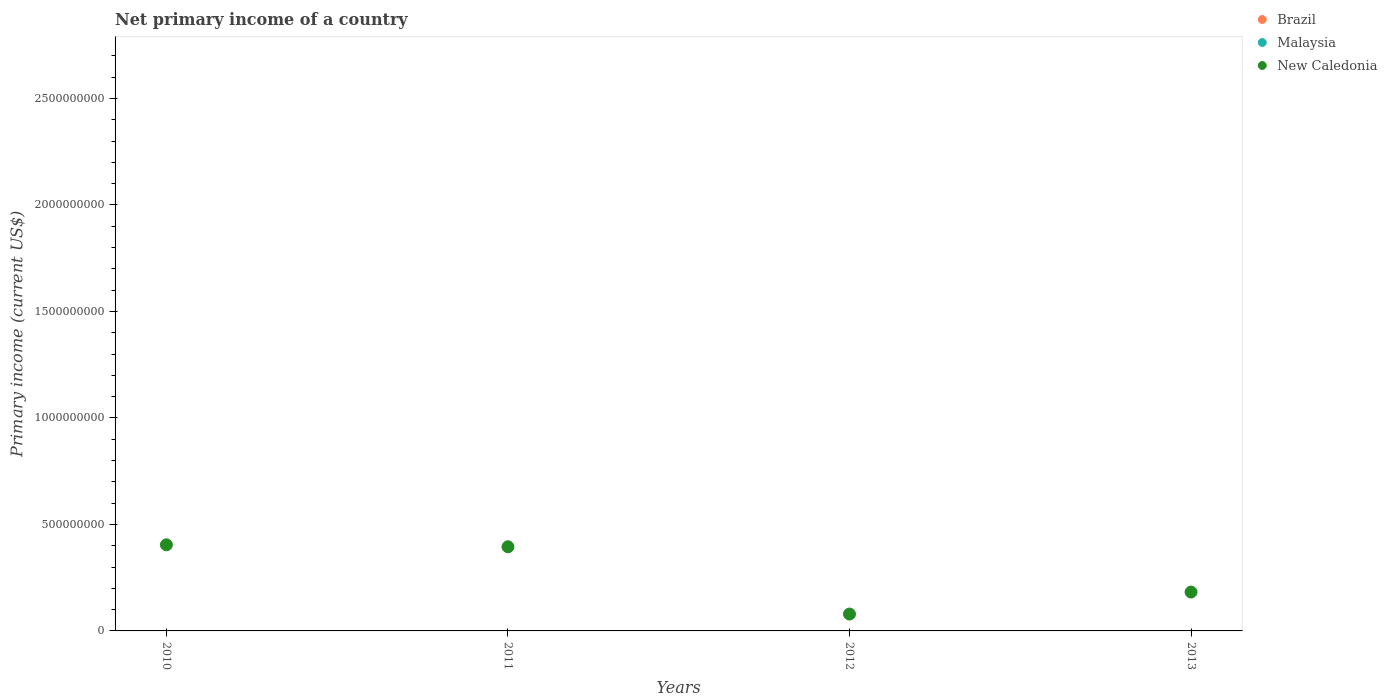Across all years, what is the maximum primary income in New Caledonia?
Your answer should be very brief. 4.04e+08. In which year was the primary income in New Caledonia maximum?
Keep it short and to the point. 2010. What is the difference between the primary income in New Caledonia in 2010 and that in 2012?
Your response must be concise. 3.25e+08. What is the difference between the primary income in New Caledonia in 2013 and the primary income in Malaysia in 2010?
Your answer should be very brief. 1.82e+08. What is the average primary income in Malaysia per year?
Provide a succinct answer. 0. What is the ratio of the primary income in New Caledonia in 2010 to that in 2012?
Offer a terse response. 5.11. What is the difference between the highest and the second highest primary income in New Caledonia?
Offer a very short reply. 9.33e+06. What is the difference between the highest and the lowest primary income in New Caledonia?
Your answer should be very brief. 3.25e+08. Is it the case that in every year, the sum of the primary income in New Caledonia and primary income in Malaysia  is greater than the primary income in Brazil?
Keep it short and to the point. Yes. Does the primary income in Malaysia monotonically increase over the years?
Offer a very short reply. No. How many years are there in the graph?
Offer a very short reply. 4. What is the difference between two consecutive major ticks on the Y-axis?
Provide a short and direct response. 5.00e+08. Are the values on the major ticks of Y-axis written in scientific E-notation?
Your answer should be compact. No. Does the graph contain grids?
Keep it short and to the point. No. Where does the legend appear in the graph?
Provide a short and direct response. Top right. What is the title of the graph?
Ensure brevity in your answer.  Net primary income of a country. Does "Middle East & North Africa (all income levels)" appear as one of the legend labels in the graph?
Your answer should be compact. No. What is the label or title of the Y-axis?
Make the answer very short. Primary income (current US$). What is the Primary income (current US$) in New Caledonia in 2010?
Make the answer very short. 4.04e+08. What is the Primary income (current US$) in Brazil in 2011?
Your answer should be very brief. 0. What is the Primary income (current US$) in New Caledonia in 2011?
Make the answer very short. 3.95e+08. What is the Primary income (current US$) in Malaysia in 2012?
Ensure brevity in your answer.  0. What is the Primary income (current US$) of New Caledonia in 2012?
Offer a very short reply. 7.92e+07. What is the Primary income (current US$) in Brazil in 2013?
Provide a short and direct response. 0. What is the Primary income (current US$) of Malaysia in 2013?
Ensure brevity in your answer.  0. What is the Primary income (current US$) in New Caledonia in 2013?
Keep it short and to the point. 1.82e+08. Across all years, what is the maximum Primary income (current US$) in New Caledonia?
Provide a short and direct response. 4.04e+08. Across all years, what is the minimum Primary income (current US$) of New Caledonia?
Your response must be concise. 7.92e+07. What is the total Primary income (current US$) in Brazil in the graph?
Keep it short and to the point. 0. What is the total Primary income (current US$) in New Caledonia in the graph?
Your response must be concise. 1.06e+09. What is the difference between the Primary income (current US$) of New Caledonia in 2010 and that in 2011?
Make the answer very short. 9.33e+06. What is the difference between the Primary income (current US$) of New Caledonia in 2010 and that in 2012?
Keep it short and to the point. 3.25e+08. What is the difference between the Primary income (current US$) of New Caledonia in 2010 and that in 2013?
Offer a terse response. 2.22e+08. What is the difference between the Primary income (current US$) of New Caledonia in 2011 and that in 2012?
Your answer should be very brief. 3.16e+08. What is the difference between the Primary income (current US$) of New Caledonia in 2011 and that in 2013?
Offer a terse response. 2.13e+08. What is the difference between the Primary income (current US$) of New Caledonia in 2012 and that in 2013?
Make the answer very short. -1.03e+08. What is the average Primary income (current US$) in Brazil per year?
Provide a short and direct response. 0. What is the average Primary income (current US$) of Malaysia per year?
Offer a terse response. 0. What is the average Primary income (current US$) in New Caledonia per year?
Provide a succinct answer. 2.65e+08. What is the ratio of the Primary income (current US$) in New Caledonia in 2010 to that in 2011?
Your response must be concise. 1.02. What is the ratio of the Primary income (current US$) in New Caledonia in 2010 to that in 2012?
Provide a succinct answer. 5.11. What is the ratio of the Primary income (current US$) of New Caledonia in 2010 to that in 2013?
Provide a succinct answer. 2.22. What is the ratio of the Primary income (current US$) of New Caledonia in 2011 to that in 2012?
Keep it short and to the point. 4.99. What is the ratio of the Primary income (current US$) in New Caledonia in 2011 to that in 2013?
Make the answer very short. 2.17. What is the ratio of the Primary income (current US$) of New Caledonia in 2012 to that in 2013?
Offer a very short reply. 0.43. What is the difference between the highest and the second highest Primary income (current US$) in New Caledonia?
Your response must be concise. 9.33e+06. What is the difference between the highest and the lowest Primary income (current US$) of New Caledonia?
Your answer should be compact. 3.25e+08. 